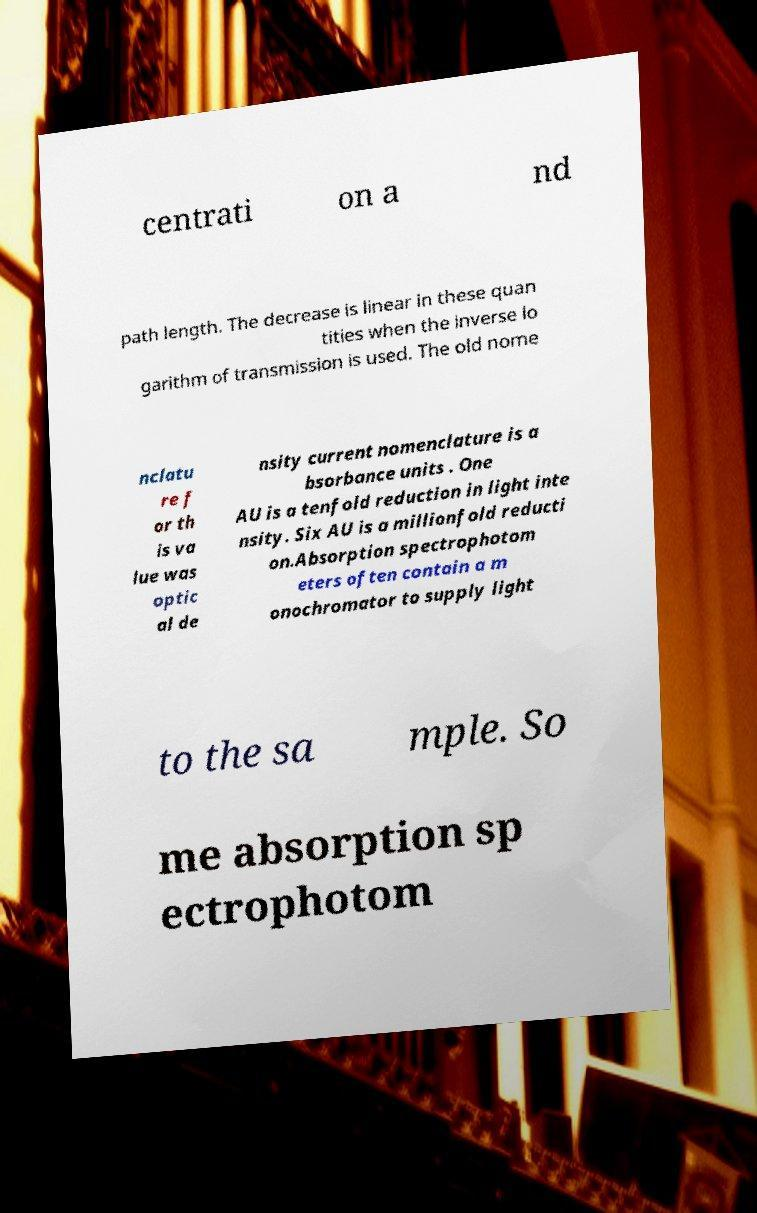Please identify and transcribe the text found in this image. centrati on a nd path length. The decrease is linear in these quan tities when the inverse lo garithm of transmission is used. The old nome nclatu re f or th is va lue was optic al de nsity current nomenclature is a bsorbance units . One AU is a tenfold reduction in light inte nsity. Six AU is a millionfold reducti on.Absorption spectrophotom eters often contain a m onochromator to supply light to the sa mple. So me absorption sp ectrophotom 